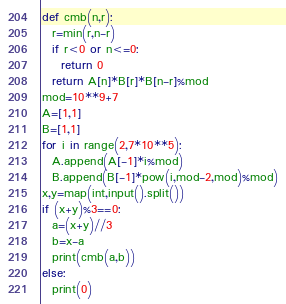Convert code to text. <code><loc_0><loc_0><loc_500><loc_500><_Python_>def cmb(n,r):
  r=min(r,n-r)
  if r<0 or n<=0:
    return 0
  return A[n]*B[r]*B[n-r]%mod
mod=10**9+7
A=[1,1]
B=[1,1]
for i in range(2,7*10**5):
  A.append(A[-1]*i%mod)
  B.append(B[-1]*pow(i,mod-2,mod)%mod)
x,y=map(int,input().split())
if (x+y)%3==0:
  a=(x+y)//3
  b=x-a
  print(cmb(a,b))
else:
  print(0)</code> 